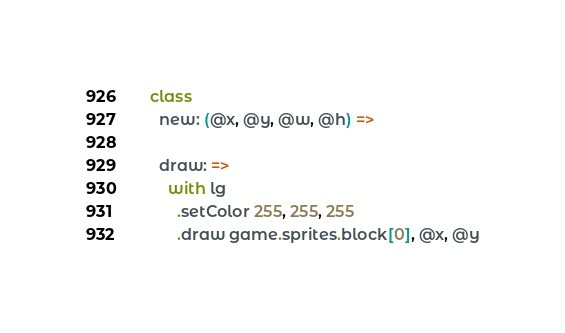Convert code to text. <code><loc_0><loc_0><loc_500><loc_500><_MoonScript_>class
  new: (@x, @y, @w, @h) =>

  draw: =>
    with lg
      .setColor 255, 255, 255
      .draw game.sprites.block[0], @x, @y
</code> 